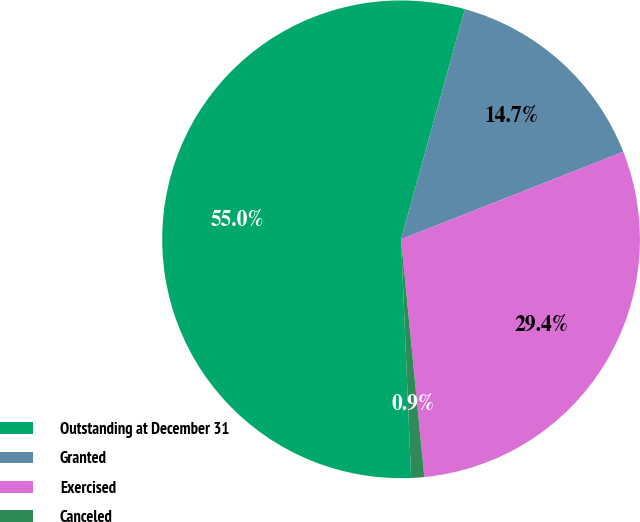Convert chart to OTSL. <chart><loc_0><loc_0><loc_500><loc_500><pie_chart><fcel>Outstanding at December 31<fcel>Granted<fcel>Exercised<fcel>Canceled<nl><fcel>54.98%<fcel>14.72%<fcel>29.42%<fcel>0.88%<nl></chart> 